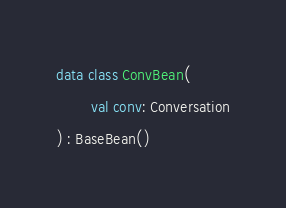Convert code to text. <code><loc_0><loc_0><loc_500><loc_500><_Kotlin_>data class ConvBean(
        val conv: Conversation
) : BaseBean()</code> 